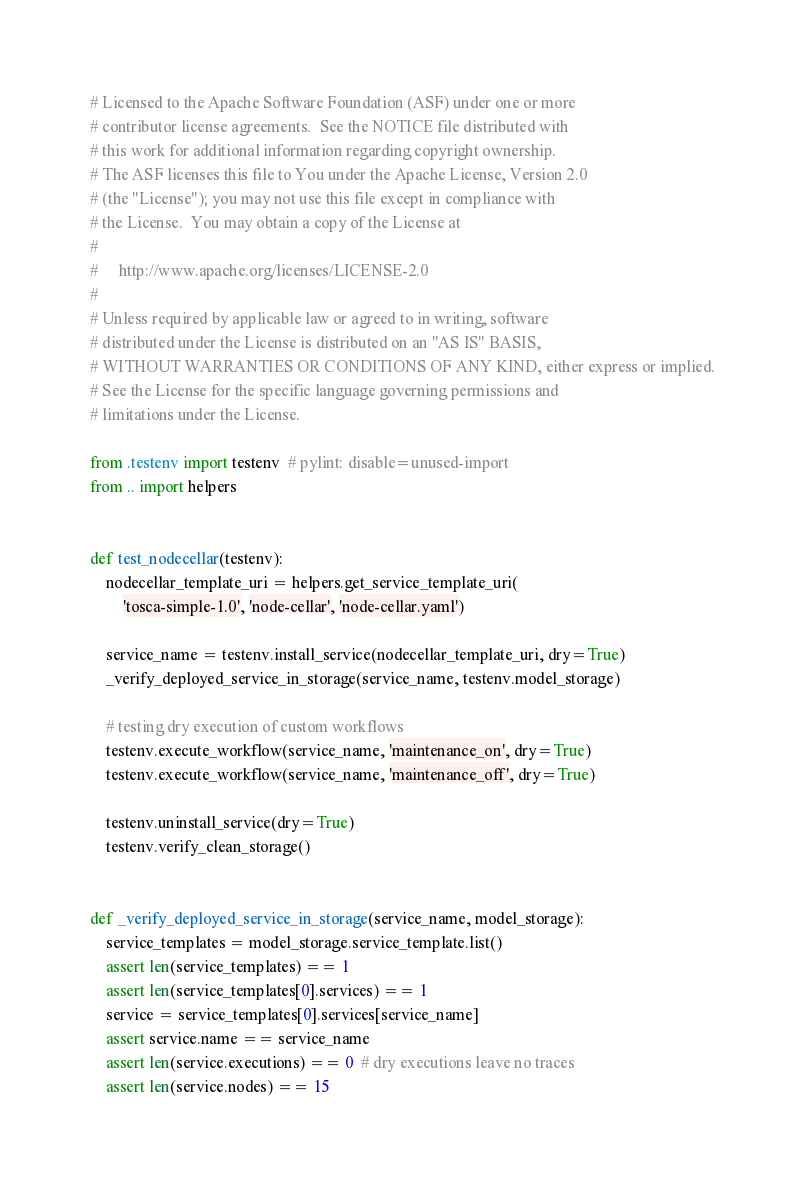Convert code to text. <code><loc_0><loc_0><loc_500><loc_500><_Python_># Licensed to the Apache Software Foundation (ASF) under one or more
# contributor license agreements.  See the NOTICE file distributed with
# this work for additional information regarding copyright ownership.
# The ASF licenses this file to You under the Apache License, Version 2.0
# (the "License"); you may not use this file except in compliance with
# the License.  You may obtain a copy of the License at
#
#     http://www.apache.org/licenses/LICENSE-2.0
#
# Unless required by applicable law or agreed to in writing, software
# distributed under the License is distributed on an "AS IS" BASIS,
# WITHOUT WARRANTIES OR CONDITIONS OF ANY KIND, either express or implied.
# See the License for the specific language governing permissions and
# limitations under the License.

from .testenv import testenv  # pylint: disable=unused-import
from .. import helpers


def test_nodecellar(testenv):
    nodecellar_template_uri = helpers.get_service_template_uri(
        'tosca-simple-1.0', 'node-cellar', 'node-cellar.yaml')

    service_name = testenv.install_service(nodecellar_template_uri, dry=True)
    _verify_deployed_service_in_storage(service_name, testenv.model_storage)

    # testing dry execution of custom workflows
    testenv.execute_workflow(service_name, 'maintenance_on', dry=True)
    testenv.execute_workflow(service_name, 'maintenance_off', dry=True)

    testenv.uninstall_service(dry=True)
    testenv.verify_clean_storage()


def _verify_deployed_service_in_storage(service_name, model_storage):
    service_templates = model_storage.service_template.list()
    assert len(service_templates) == 1
    assert len(service_templates[0].services) == 1
    service = service_templates[0].services[service_name]
    assert service.name == service_name
    assert len(service.executions) == 0  # dry executions leave no traces
    assert len(service.nodes) == 15
</code> 